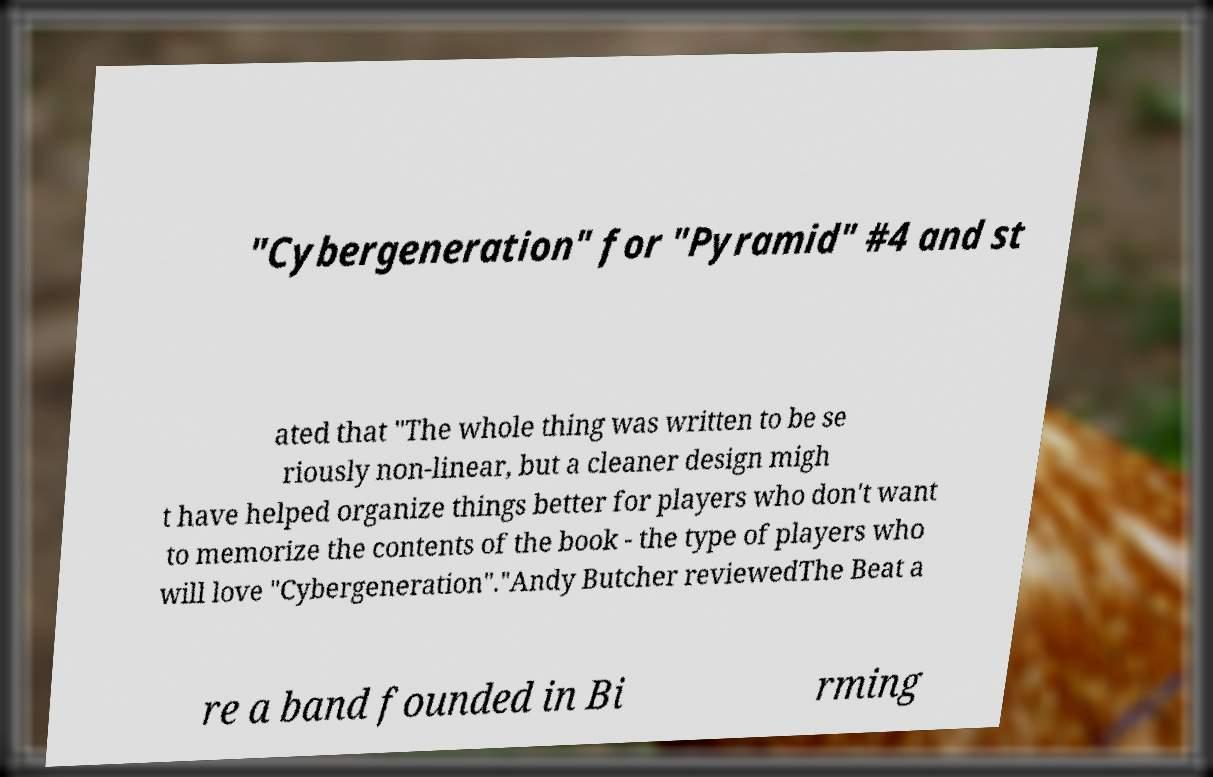There's text embedded in this image that I need extracted. Can you transcribe it verbatim? "Cybergeneration" for "Pyramid" #4 and st ated that "The whole thing was written to be se riously non-linear, but a cleaner design migh t have helped organize things better for players who don't want to memorize the contents of the book - the type of players who will love "Cybergeneration"."Andy Butcher reviewedThe Beat a re a band founded in Bi rming 